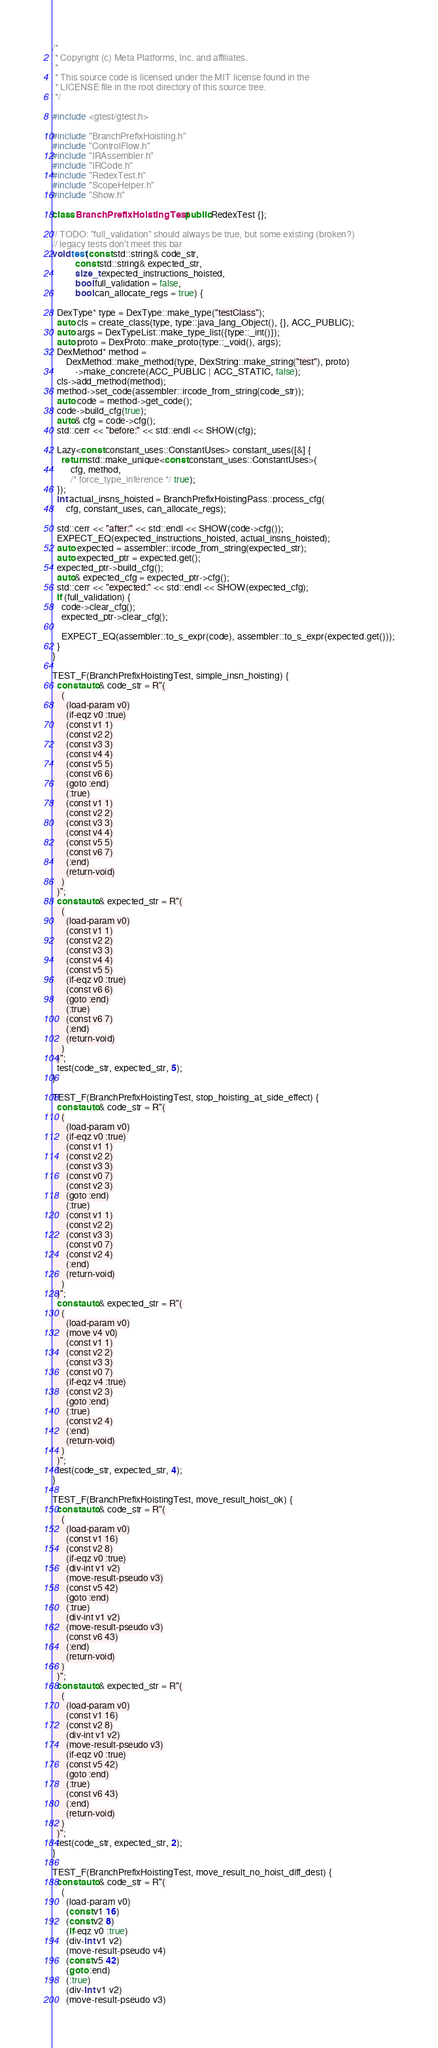<code> <loc_0><loc_0><loc_500><loc_500><_C++_>/*
 * Copyright (c) Meta Platforms, Inc. and affiliates.
 *
 * This source code is licensed under the MIT license found in the
 * LICENSE file in the root directory of this source tree.
 */

#include <gtest/gtest.h>

#include "BranchPrefixHoisting.h"
#include "ControlFlow.h"
#include "IRAssembler.h"
#include "IRCode.h"
#include "RedexTest.h"
#include "ScopeHelper.h"
#include "Show.h"

class BranchPrefixHoistingTest : public RedexTest {};

// TODO: "full_validation" should always be true, but some existing (broken?)
// legacy tests don't meet this bar
void test(const std::string& code_str,
          const std::string& expected_str,
          size_t expected_instructions_hoisted,
          bool full_validation = false,
          bool can_allocate_regs = true) {

  DexType* type = DexType::make_type("testClass");
  auto cls = create_class(type, type::java_lang_Object(), {}, ACC_PUBLIC);
  auto args = DexTypeList::make_type_list({type::_int()});
  auto proto = DexProto::make_proto(type::_void(), args);
  DexMethod* method =
      DexMethod::make_method(type, DexString::make_string("test"), proto)
          ->make_concrete(ACC_PUBLIC | ACC_STATIC, false);
  cls->add_method(method);
  method->set_code(assembler::ircode_from_string(code_str));
  auto code = method->get_code();
  code->build_cfg(true);
  auto& cfg = code->cfg();
  std::cerr << "before:" << std::endl << SHOW(cfg);

  Lazy<const constant_uses::ConstantUses> constant_uses([&] {
    return std::make_unique<const constant_uses::ConstantUses>(
        cfg, method,
        /* force_type_inference */ true);
  });
  int actual_insns_hoisted = BranchPrefixHoistingPass::process_cfg(
      cfg, constant_uses, can_allocate_regs);

  std::cerr << "after:" << std::endl << SHOW(code->cfg());
  EXPECT_EQ(expected_instructions_hoisted, actual_insns_hoisted);
  auto expected = assembler::ircode_from_string(expected_str);
  auto expected_ptr = expected.get();
  expected_ptr->build_cfg();
  auto& expected_cfg = expected_ptr->cfg();
  std::cerr << "expected:" << std::endl << SHOW(expected_cfg);
  if (full_validation) {
    code->clear_cfg();
    expected_ptr->clear_cfg();

    EXPECT_EQ(assembler::to_s_expr(code), assembler::to_s_expr(expected.get()));
  }
}

TEST_F(BranchPrefixHoistingTest, simple_insn_hoisting) {
  const auto& code_str = R"(
    (
      (load-param v0)
      (if-eqz v0 :true)
      (const v1 1)
      (const v2 2)
      (const v3 3)
      (const v4 4)
      (const v5 5)
      (const v6 6)
      (goto :end)
      (:true)
      (const v1 1)
      (const v2 2)
      (const v3 3)
      (const v4 4)
      (const v5 5)
      (const v6 7)
      (:end)
      (return-void)
    )
  )";
  const auto& expected_str = R"(
    (
      (load-param v0)
      (const v1 1)
      (const v2 2)
      (const v3 3)
      (const v4 4)
      (const v5 5)
      (if-eqz v0 :true)
      (const v6 6)
      (goto :end)
      (:true)
      (const v6 7)
      (:end)
      (return-void)
    )
  )";
  test(code_str, expected_str, 5);
}

TEST_F(BranchPrefixHoistingTest, stop_hoisting_at_side_effect) {
  const auto& code_str = R"(
    (
      (load-param v0)
      (if-eqz v0 :true)
      (const v1 1)
      (const v2 2)
      (const v3 3)
      (const v0 7)
      (const v2 3)
      (goto :end)
      (:true)
      (const v1 1)
      (const v2 2)
      (const v3 3)
      (const v0 7)
      (const v2 4)
      (:end)
      (return-void)
    )
  )";
  const auto& expected_str = R"(
    (
      (load-param v0)
      (move v4 v0)
      (const v1 1)
      (const v2 2)
      (const v3 3)
      (const v0 7)
      (if-eqz v4 :true)
      (const v2 3)
      (goto :end)
      (:true)
      (const v2 4)
      (:end)
      (return-void)
    )
  )";
  test(code_str, expected_str, 4);
}

TEST_F(BranchPrefixHoistingTest, move_result_hoist_ok) {
  const auto& code_str = R"(
    (
      (load-param v0)
      (const v1 16)
      (const v2 8)
      (if-eqz v0 :true)
      (div-int v1 v2)
      (move-result-pseudo v3)
      (const v5 42)
      (goto :end)
      (:true)
      (div-int v1 v2)
      (move-result-pseudo v3)
      (const v6 43)
      (:end)
      (return-void)
    )
  )";
  const auto& expected_str = R"(
    (
      (load-param v0)
      (const v1 16)
      (const v2 8)
      (div-int v1 v2)
      (move-result-pseudo v3)
      (if-eqz v0 :true)
      (const v5 42)
      (goto :end)
      (:true)
      (const v6 43)
      (:end)
      (return-void)
    )
  )";
  test(code_str, expected_str, 2);
}

TEST_F(BranchPrefixHoistingTest, move_result_no_hoist_diff_dest) {
  const auto& code_str = R"(
    (
      (load-param v0)
      (const v1 16)
      (const v2 8)
      (if-eqz v0 :true)
      (div-int v1 v2)
      (move-result-pseudo v4)
      (const v5 42)
      (goto :end)
      (:true)
      (div-int v1 v2)
      (move-result-pseudo v3)</code> 